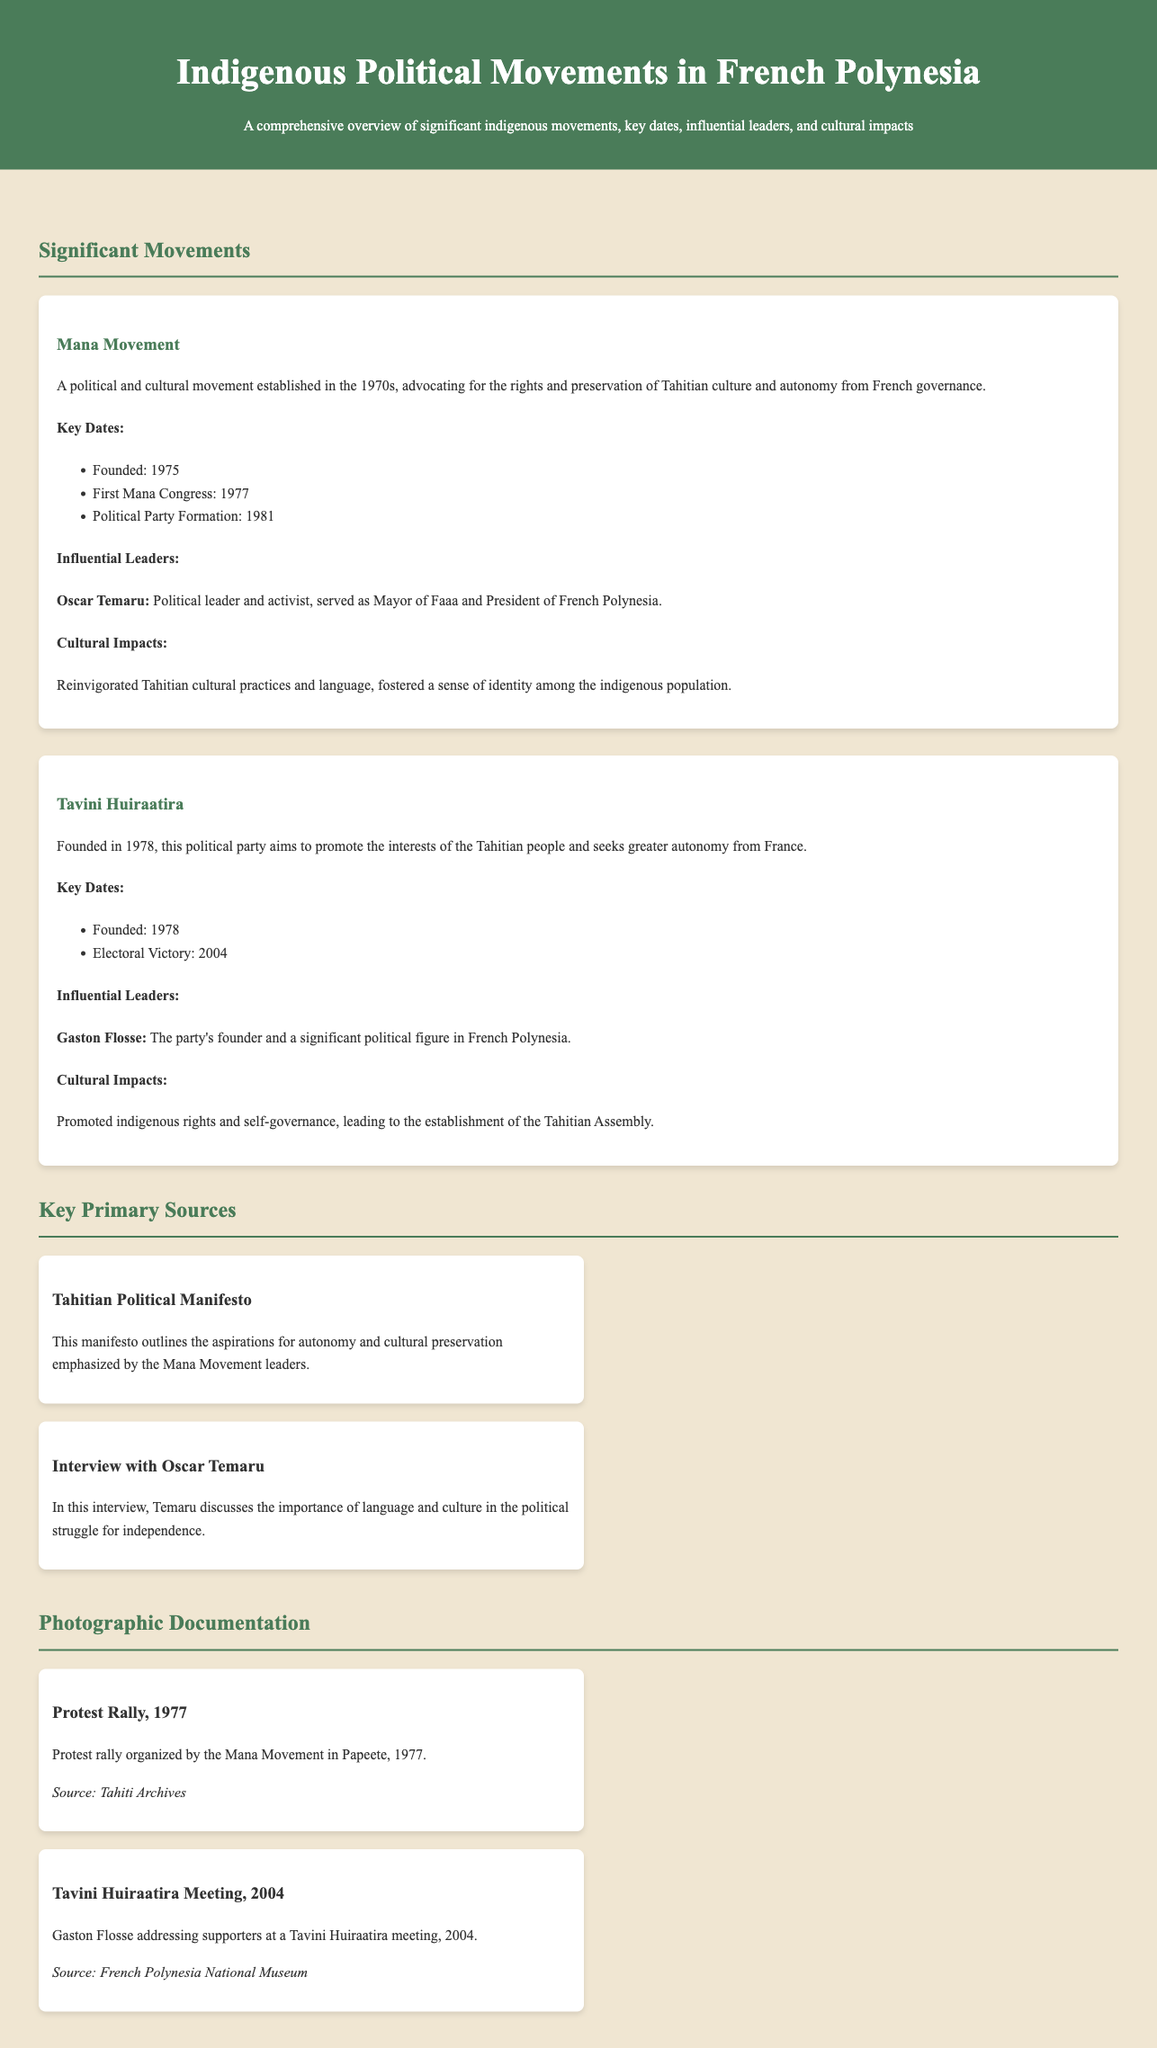What year was the Mana Movement founded? The document states that the Mana Movement was founded in 1975.
Answer: 1975 Who is a key leader of the Mana Movement? The document specifies Oscar Temaru as a significant leader of the Mana Movement.
Answer: Oscar Temaru What was the first Mana Congress year? According to the document, the first Mana Congress took place in 1977.
Answer: 1977 What is the focus of the Tavini Huiraatira party? The document mentions that Tavini Huiraatira aims to promote the interests of the Tahitian people and seeks greater autonomy from France.
Answer: Greater autonomy What major event took place for Tavini Huiraatira in 2004? The document indicates that Tavini Huiraatira experienced an electoral victory in 2004.
Answer: Electoral victory What type of source is the "Tahitian Political Manifesto"? The document categorizes it as a primary source outlining aspirations for autonomy and cultural preservation.
Answer: Primary source What cultural impact did the Mana Movement have? The document states that the Mana Movement reinvigorated Tahitian cultural practices and language.
Answer: Reinvigorated cultural practices What significant activity occurred in 1977 related to the Mana Movement? The document describes a protest rally organized by the Mana Movement in Papeete in 1977.
Answer: Protest rally Who led the Tavini Huiraatira meeting in 2004? The document mentions Gaston Flosse as addressing supporters at the Tavini Huiraatira meeting in 2004.
Answer: Gaston Flosse 